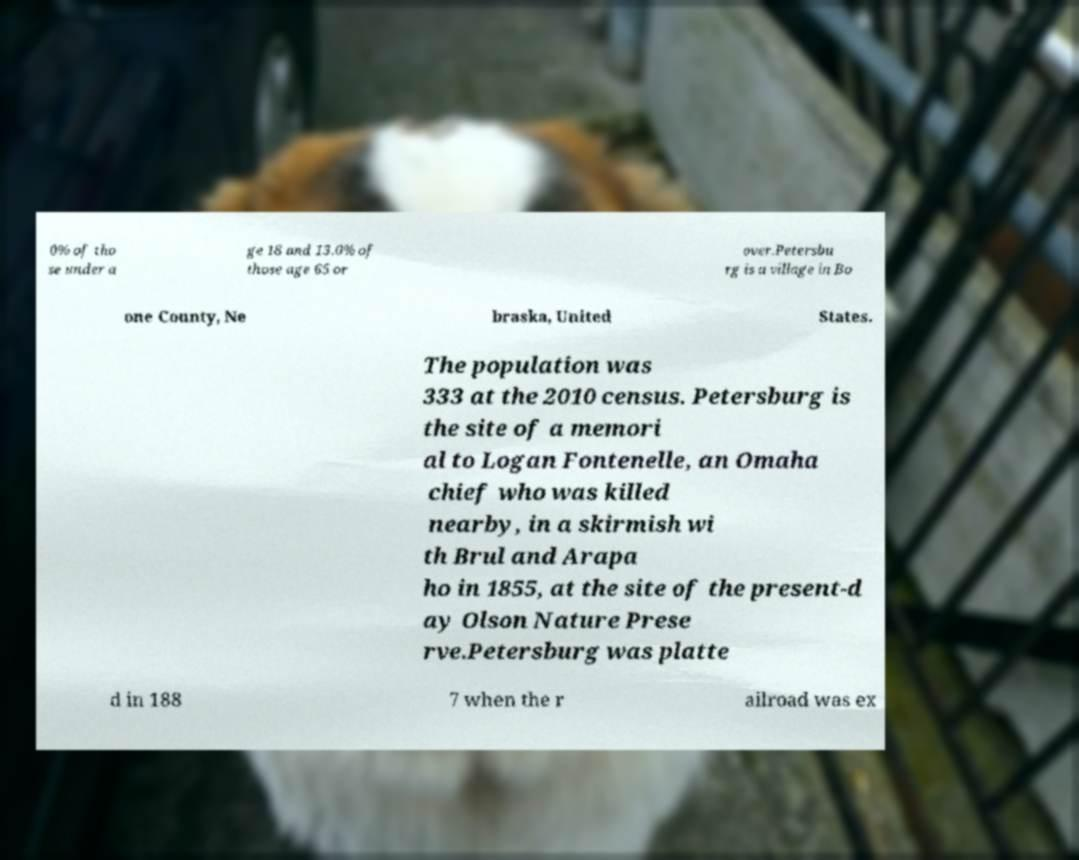Please read and relay the text visible in this image. What does it say? 0% of tho se under a ge 18 and 13.0% of those age 65 or over.Petersbu rg is a village in Bo one County, Ne braska, United States. The population was 333 at the 2010 census. Petersburg is the site of a memori al to Logan Fontenelle, an Omaha chief who was killed nearby, in a skirmish wi th Brul and Arapa ho in 1855, at the site of the present-d ay Olson Nature Prese rve.Petersburg was platte d in 188 7 when the r ailroad was ex 